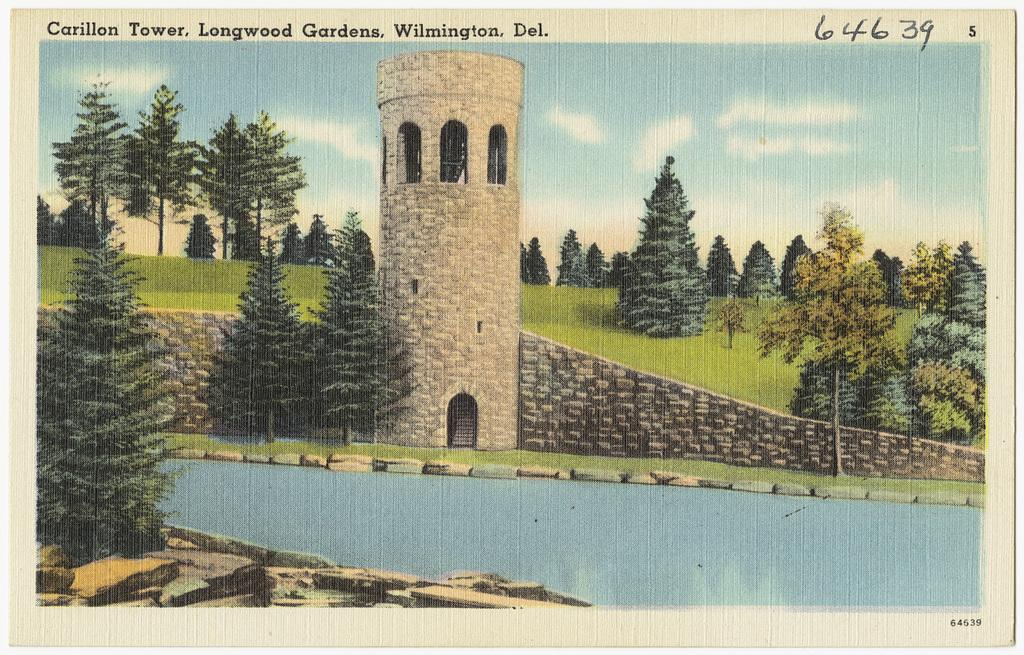What is depicted on the paper in the image? There is a painting on the paper. What elements can be found in the painting? The painting contains trees, a wall, a tower, the sky, and water. What is the purpose of the text on the paper? The text on the paper provides additional information or context about the painting. How does the bat interact with the painting on the paper? There is no bat present in the image; it only contains a painting on paper with text. 